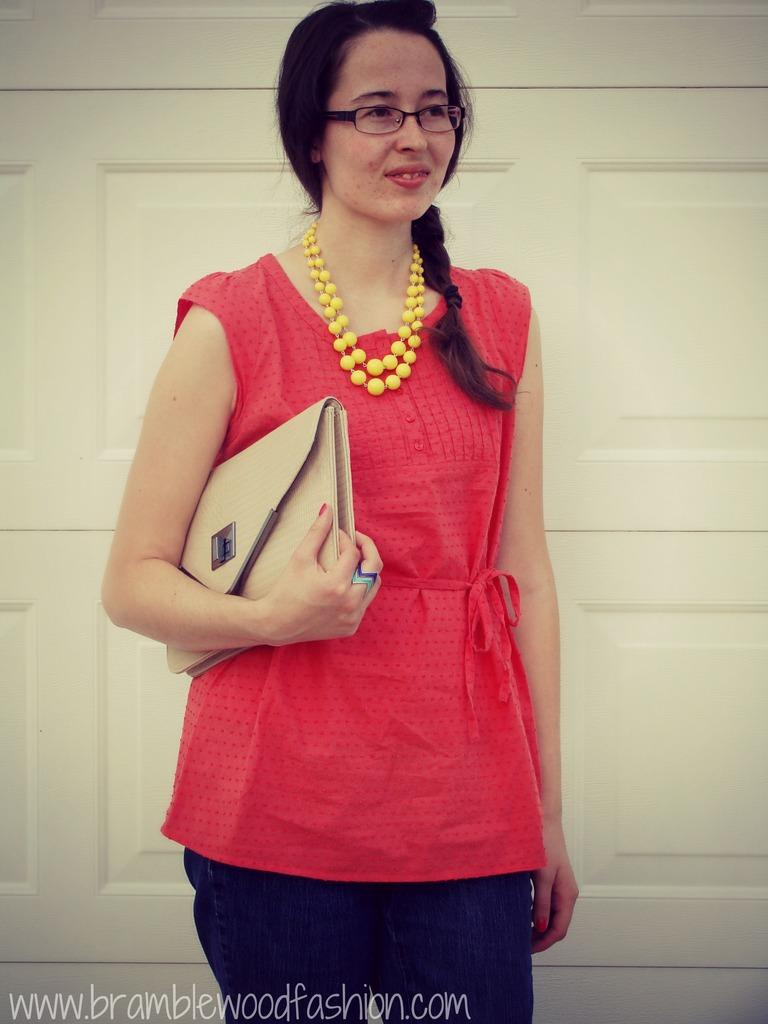Who is the main subject in the image? There is a woman in the image. Where is the woman positioned in the image? The woman is standing in the center of the image. What is the woman's facial expression? The woman is smiling. What is the woman holding in her hand? The woman is holding a purse in her hand. What can be seen in the background of the image? There is a cream-colored door in the background of the image. What type of bean is growing on the woman's head in the image? There is no bean growing on the woman's head in the image. 